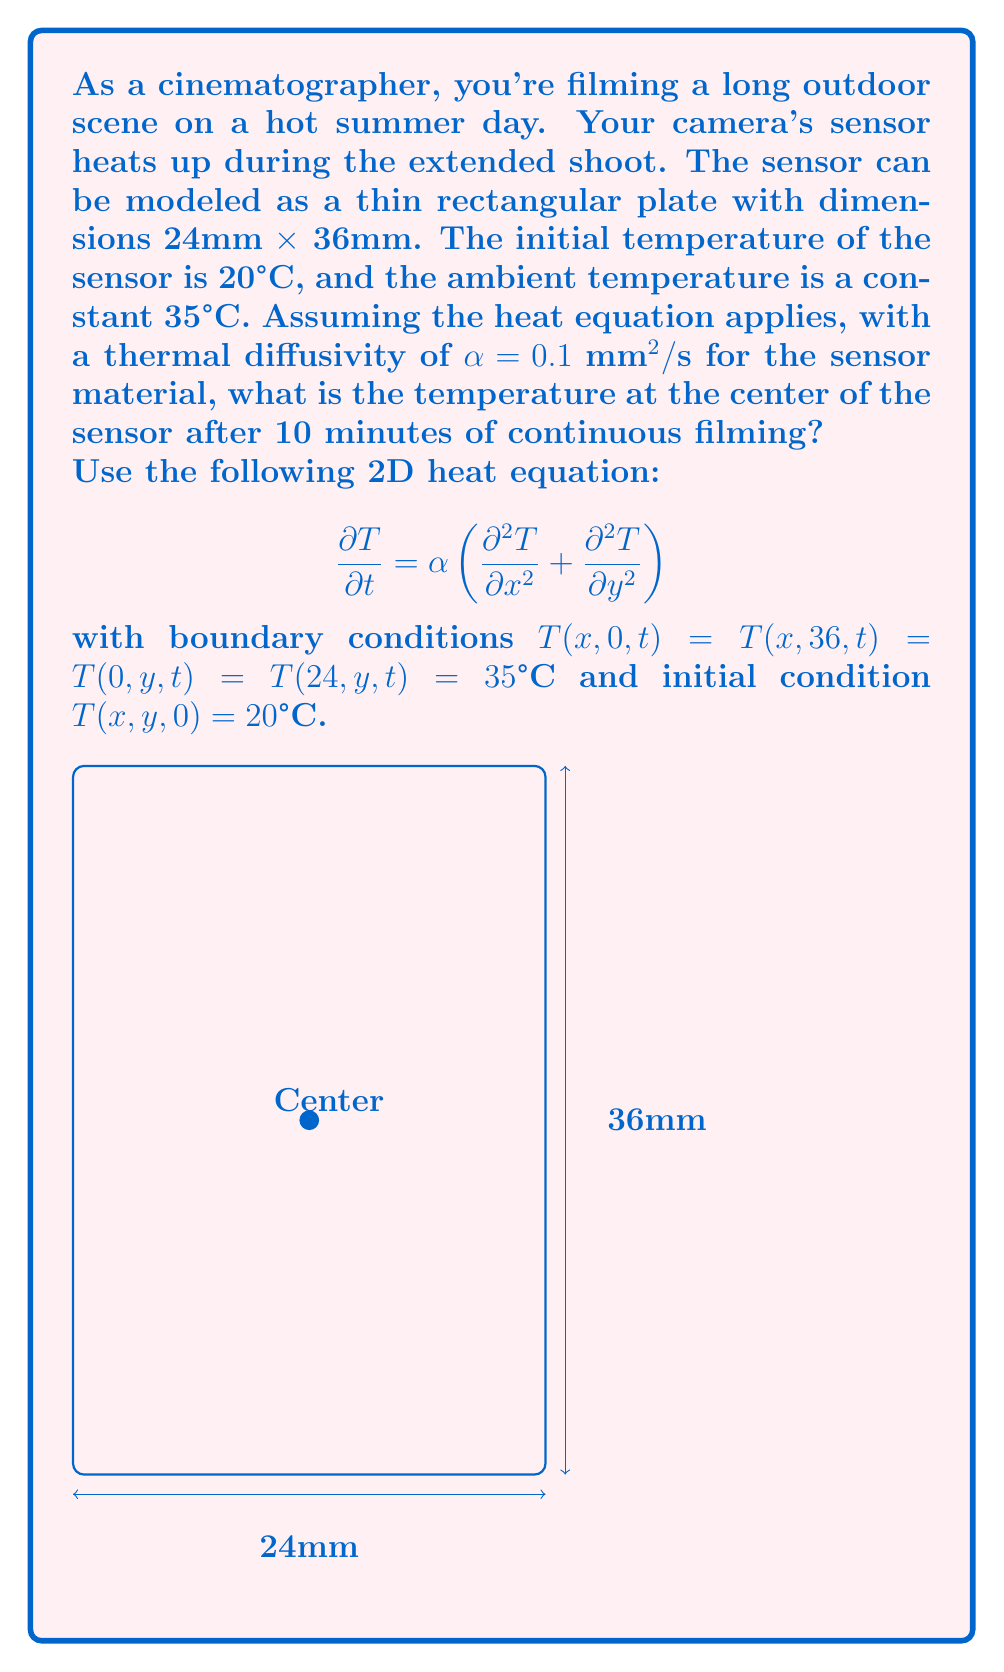Help me with this question. To solve this problem, we'll use separation of variables and Fourier series. The solution has the form:

$$T(x,y,t) = 35 + \sum_{m=1}^{\infty}\sum_{n=1}^{\infty} A_{mn} \sin\left(\frac{m\pi x}{24}\right) \sin\left(\frac{n\pi y}{36}\right) e^{-\alpha(\frac{m^2\pi^2}{24^2}+\frac{n^2\pi^2}{36^2})t}$$

where $A_{mn}$ are Fourier coefficients determined by the initial condition:

$$A_{mn} = \frac{4}{24 \cdot 36} \int_0^{24}\int_0^{36} (20-35) \sin\left(\frac{m\pi x}{24}\right) \sin\left(\frac{n\pi y}{36}\right) dx dy$$

$$= -\frac{16 \cdot 35}{\pi^2 mn} \left(1 - (-1)^m\right)\left(1 - (-1)^n\right)$$

The temperature at the center $(x=12, y=18)$ after 10 minutes $(t=600s)$ is:

$$T(12,18,600) = 35 - \sum_{m=1,3,5,...}^{\infty}\sum_{n=1,3,5,...}^{\infty} \frac{64 \cdot 35}{\pi^2 mn} \sin\left(\frac{m\pi}{2}\right) \sin\left(\frac{n\pi}{2}\right) e^{-0.1(\frac{m^2\pi^2}{24^2}+\frac{n^2\pi^2}{36^2})600}$$

Calculating the first few terms of this series (e.g., up to $m=n=5$) using a computer or calculator gives an approximate result of 34.9°C.
Answer: 34.9°C 